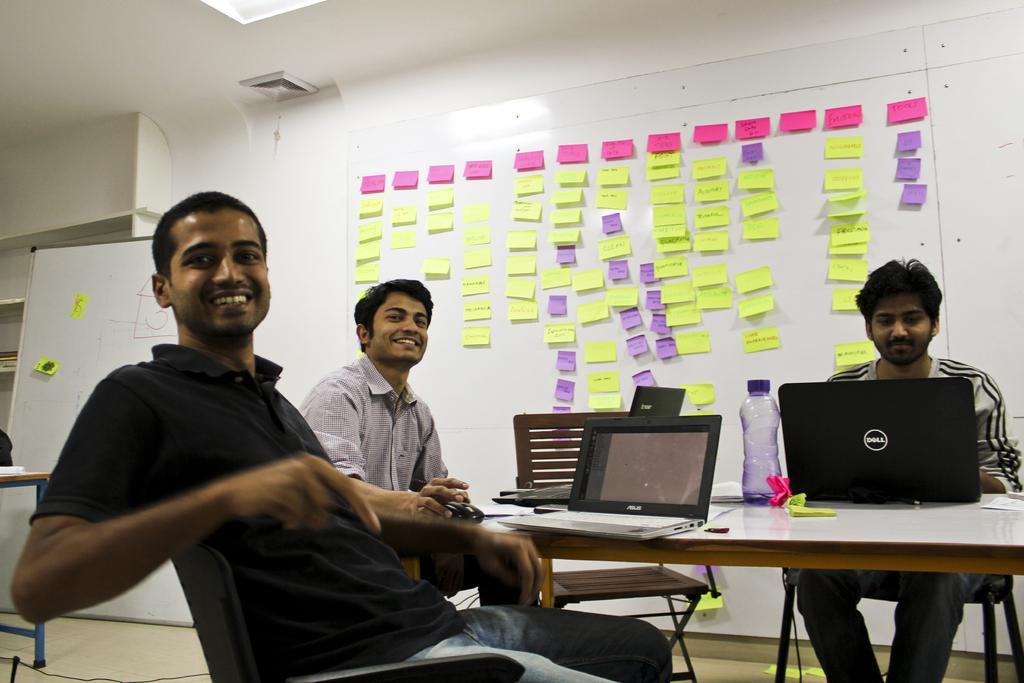Please provide a concise description of this image. In this picture we can see three people sitting on the chairs in front of the table on which there are some laptops, bottle and some clips and behind them there is a wall on which some stick notes are pasted of pink, yellow and white color and beside them there is a white board on the floor and a table. 